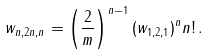Convert formula to latex. <formula><loc_0><loc_0><loc_500><loc_500>w _ { n , 2 n , n } = \left ( \frac { 2 } { m } \right ) ^ { n - 1 } ( w _ { 1 , 2 , 1 } ) ^ { n } n ! \, .</formula> 